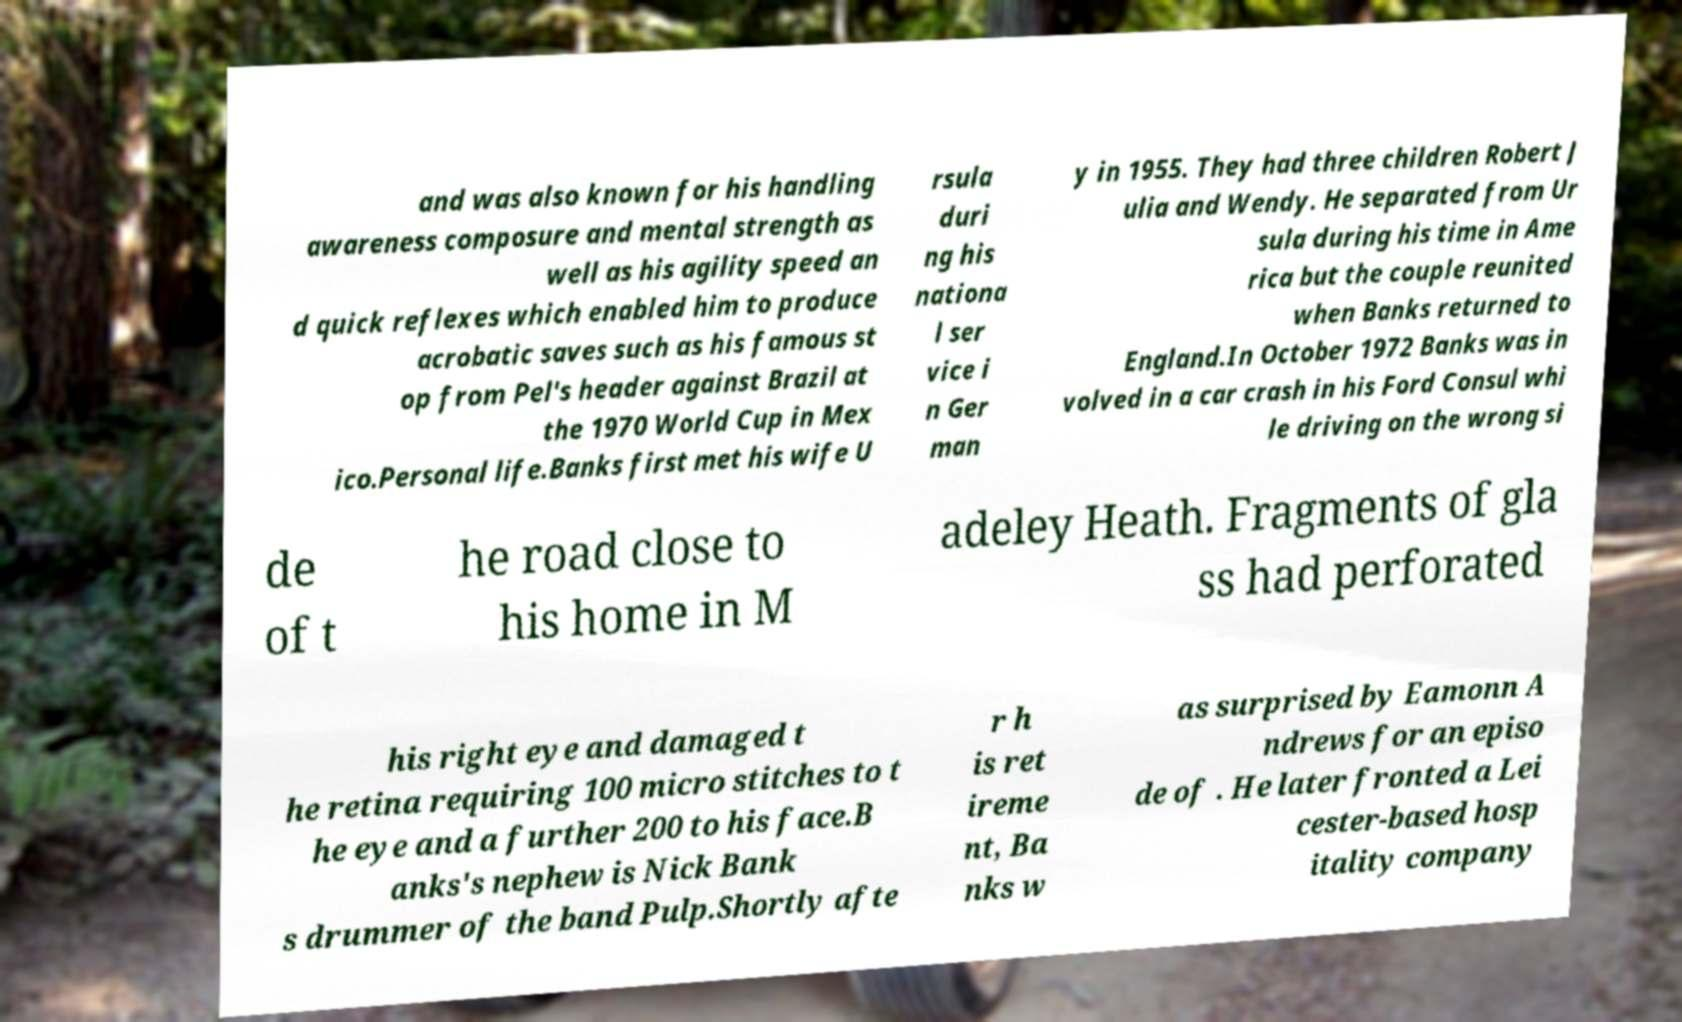Please identify and transcribe the text found in this image. and was also known for his handling awareness composure and mental strength as well as his agility speed an d quick reflexes which enabled him to produce acrobatic saves such as his famous st op from Pel's header against Brazil at the 1970 World Cup in Mex ico.Personal life.Banks first met his wife U rsula duri ng his nationa l ser vice i n Ger man y in 1955. They had three children Robert J ulia and Wendy. He separated from Ur sula during his time in Ame rica but the couple reunited when Banks returned to England.In October 1972 Banks was in volved in a car crash in his Ford Consul whi le driving on the wrong si de of t he road close to his home in M adeley Heath. Fragments of gla ss had perforated his right eye and damaged t he retina requiring 100 micro stitches to t he eye and a further 200 to his face.B anks's nephew is Nick Bank s drummer of the band Pulp.Shortly afte r h is ret ireme nt, Ba nks w as surprised by Eamonn A ndrews for an episo de of . He later fronted a Lei cester-based hosp itality company 